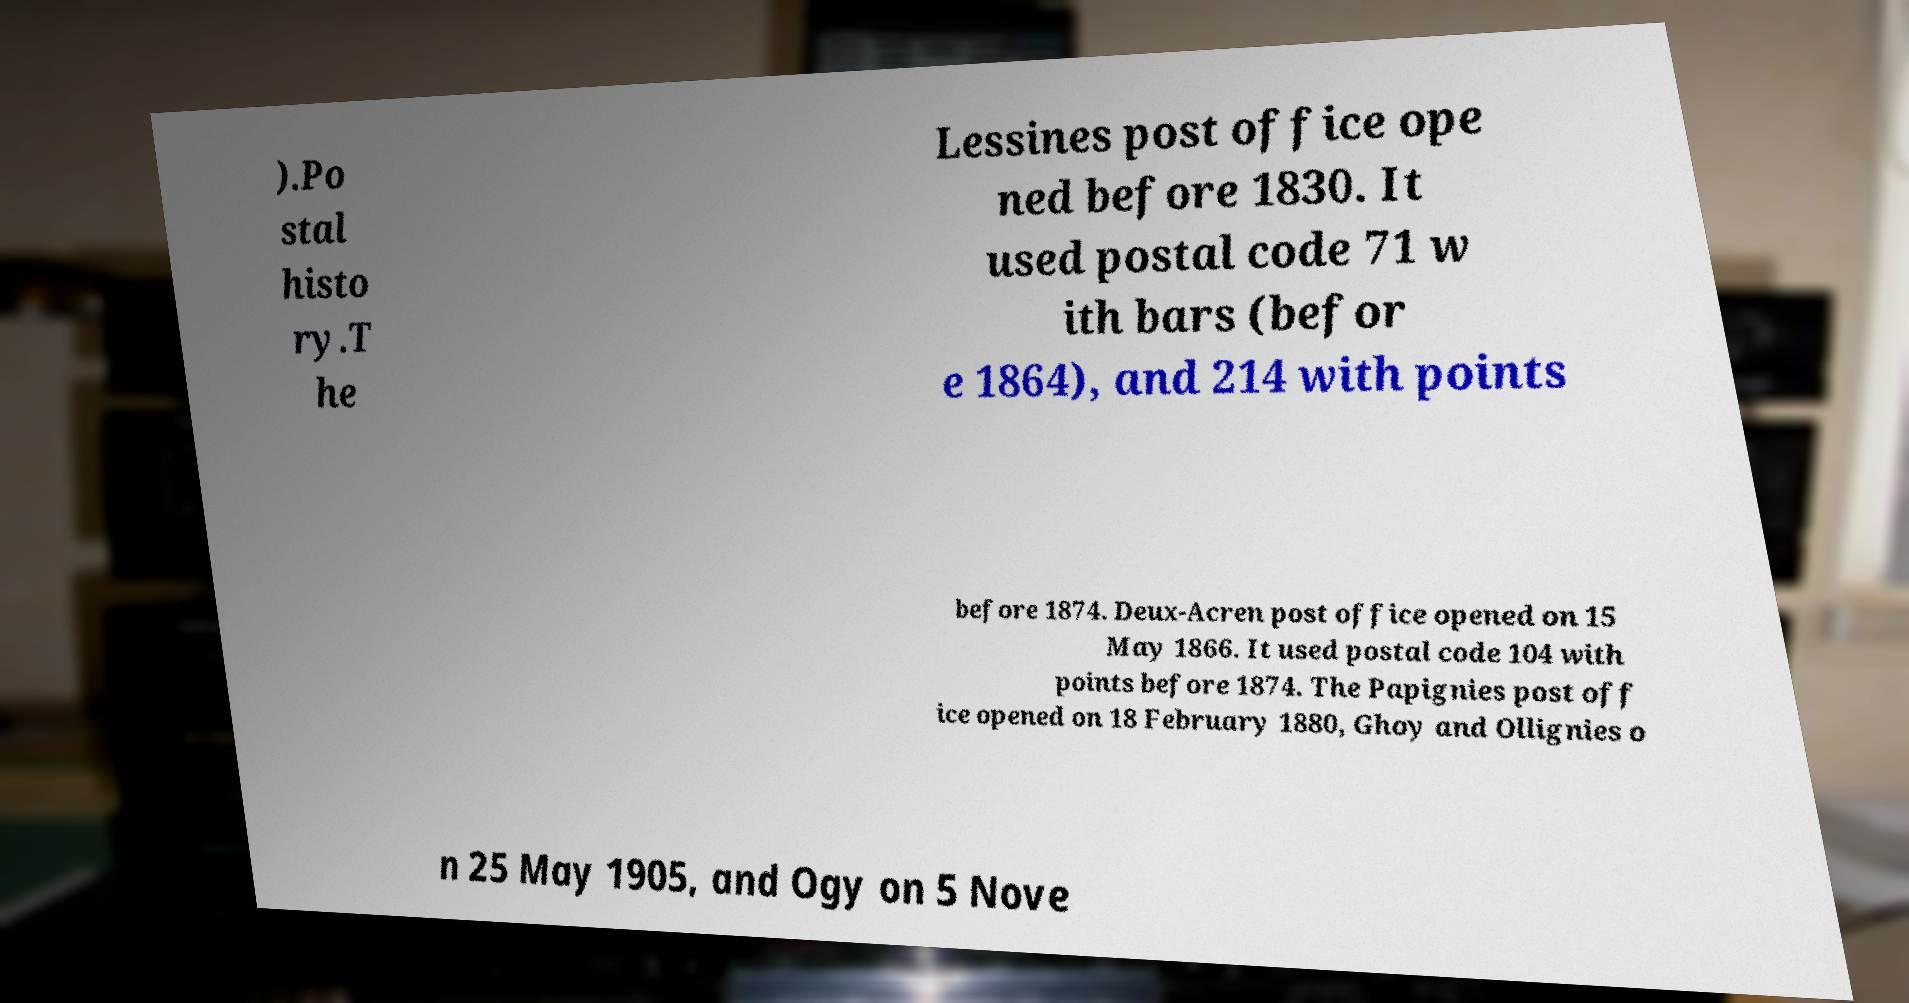Can you read and provide the text displayed in the image?This photo seems to have some interesting text. Can you extract and type it out for me? ).Po stal histo ry.T he Lessines post office ope ned before 1830. It used postal code 71 w ith bars (befor e 1864), and 214 with points before 1874. Deux-Acren post office opened on 15 May 1866. It used postal code 104 with points before 1874. The Papignies post off ice opened on 18 February 1880, Ghoy and Ollignies o n 25 May 1905, and Ogy on 5 Nove 